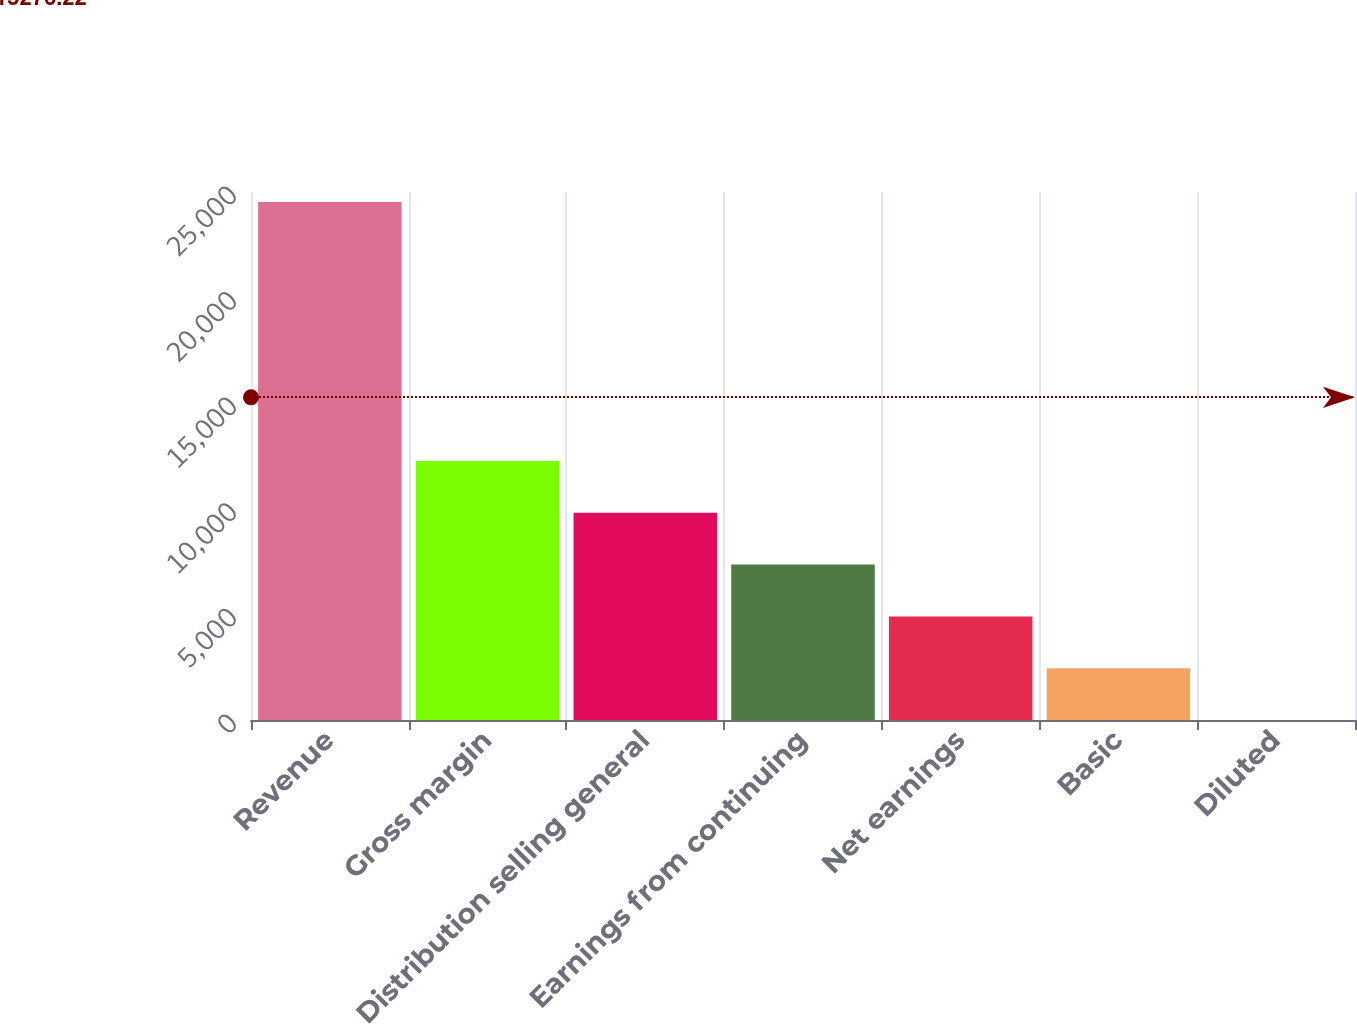Convert chart to OTSL. <chart><loc_0><loc_0><loc_500><loc_500><bar_chart><fcel>Revenue<fcel>Gross margin<fcel>Distribution selling general<fcel>Earnings from continuing<fcel>Net earnings<fcel>Basic<fcel>Diluted<nl><fcel>24523<fcel>12262<fcel>9809.79<fcel>7357.59<fcel>4905.39<fcel>2453.19<fcel>0.99<nl></chart> 